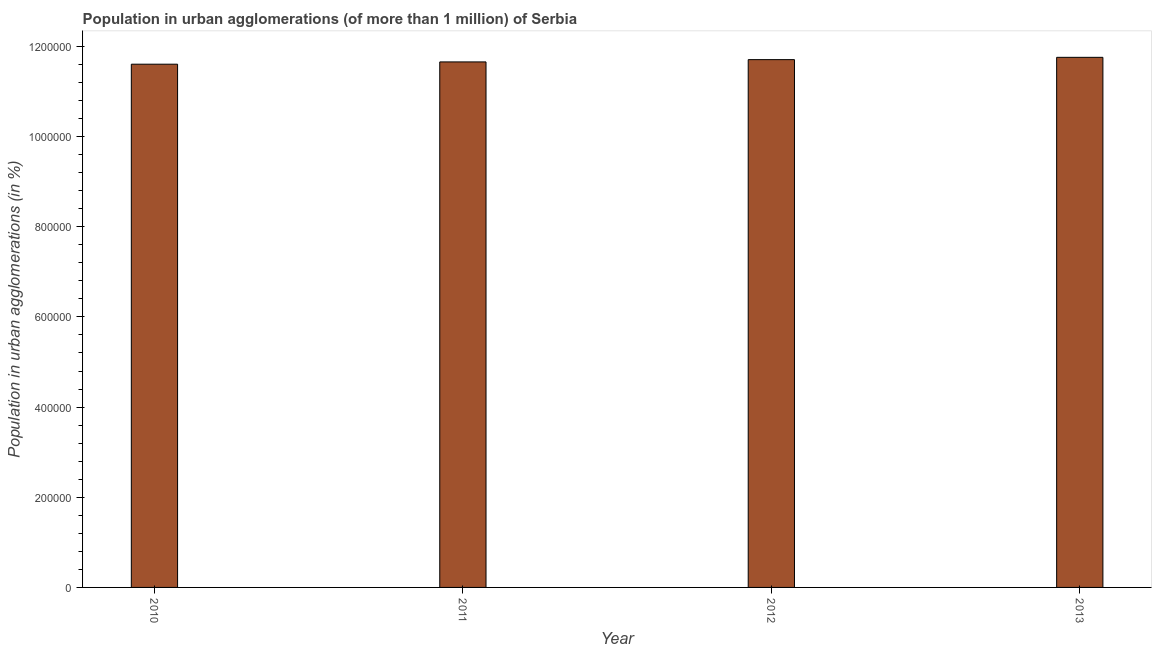Does the graph contain grids?
Offer a very short reply. No. What is the title of the graph?
Offer a very short reply. Population in urban agglomerations (of more than 1 million) of Serbia. What is the label or title of the X-axis?
Provide a succinct answer. Year. What is the label or title of the Y-axis?
Your answer should be compact. Population in urban agglomerations (in %). What is the population in urban agglomerations in 2012?
Give a very brief answer. 1.17e+06. Across all years, what is the maximum population in urban agglomerations?
Give a very brief answer. 1.18e+06. Across all years, what is the minimum population in urban agglomerations?
Provide a short and direct response. 1.16e+06. In which year was the population in urban agglomerations minimum?
Make the answer very short. 2010. What is the sum of the population in urban agglomerations?
Provide a short and direct response. 4.67e+06. What is the difference between the population in urban agglomerations in 2011 and 2012?
Your answer should be compact. -5076. What is the average population in urban agglomerations per year?
Ensure brevity in your answer.  1.17e+06. What is the median population in urban agglomerations?
Keep it short and to the point. 1.17e+06. In how many years, is the population in urban agglomerations greater than 400000 %?
Provide a short and direct response. 4. What is the difference between the highest and the second highest population in urban agglomerations?
Offer a terse response. 5098. Is the sum of the population in urban agglomerations in 2010 and 2012 greater than the maximum population in urban agglomerations across all years?
Your answer should be very brief. Yes. What is the difference between the highest and the lowest population in urban agglomerations?
Your answer should be compact. 1.52e+04. In how many years, is the population in urban agglomerations greater than the average population in urban agglomerations taken over all years?
Make the answer very short. 2. How many bars are there?
Offer a very short reply. 4. What is the difference between two consecutive major ticks on the Y-axis?
Provide a short and direct response. 2.00e+05. What is the Population in urban agglomerations (in %) in 2010?
Your response must be concise. 1.16e+06. What is the Population in urban agglomerations (in %) of 2011?
Provide a succinct answer. 1.17e+06. What is the Population in urban agglomerations (in %) of 2012?
Provide a succinct answer. 1.17e+06. What is the Population in urban agglomerations (in %) of 2013?
Keep it short and to the point. 1.18e+06. What is the difference between the Population in urban agglomerations (in %) in 2010 and 2011?
Your answer should be compact. -5047. What is the difference between the Population in urban agglomerations (in %) in 2010 and 2012?
Give a very brief answer. -1.01e+04. What is the difference between the Population in urban agglomerations (in %) in 2010 and 2013?
Ensure brevity in your answer.  -1.52e+04. What is the difference between the Population in urban agglomerations (in %) in 2011 and 2012?
Give a very brief answer. -5076. What is the difference between the Population in urban agglomerations (in %) in 2011 and 2013?
Your response must be concise. -1.02e+04. What is the difference between the Population in urban agglomerations (in %) in 2012 and 2013?
Provide a short and direct response. -5098. What is the ratio of the Population in urban agglomerations (in %) in 2010 to that in 2011?
Keep it short and to the point. 1. What is the ratio of the Population in urban agglomerations (in %) in 2010 to that in 2012?
Offer a very short reply. 0.99. What is the ratio of the Population in urban agglomerations (in %) in 2012 to that in 2013?
Give a very brief answer. 1. 